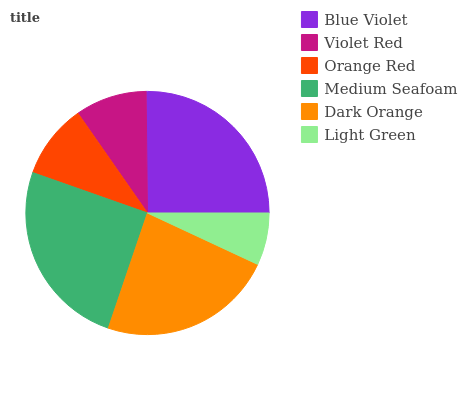Is Light Green the minimum?
Answer yes or no. Yes. Is Blue Violet the maximum?
Answer yes or no. Yes. Is Violet Red the minimum?
Answer yes or no. No. Is Violet Red the maximum?
Answer yes or no. No. Is Blue Violet greater than Violet Red?
Answer yes or no. Yes. Is Violet Red less than Blue Violet?
Answer yes or no. Yes. Is Violet Red greater than Blue Violet?
Answer yes or no. No. Is Blue Violet less than Violet Red?
Answer yes or no. No. Is Dark Orange the high median?
Answer yes or no. Yes. Is Orange Red the low median?
Answer yes or no. Yes. Is Blue Violet the high median?
Answer yes or no. No. Is Violet Red the low median?
Answer yes or no. No. 